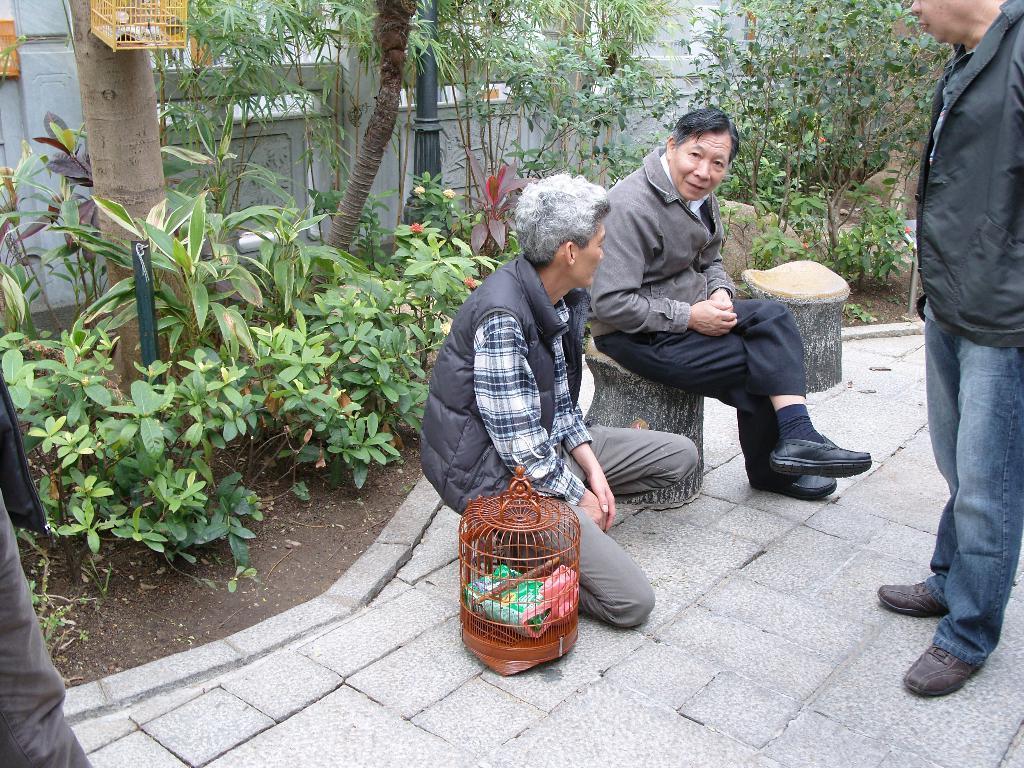In one or two sentences, can you explain what this image depicts? In this image I can see three persons. In the background I can see few plants and trees. 